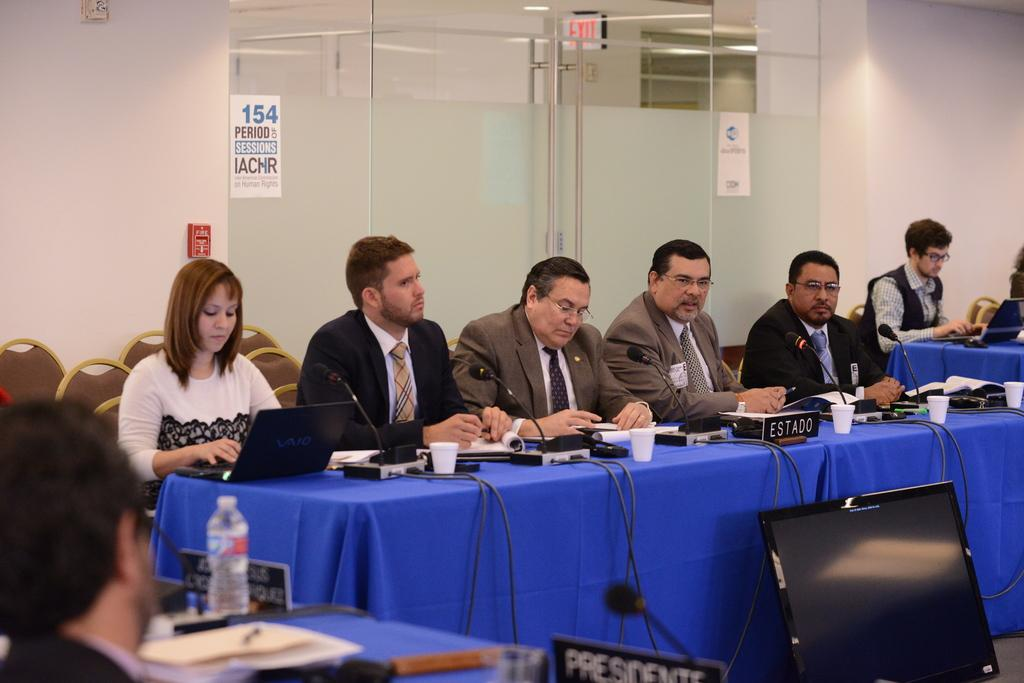<image>
Render a clear and concise summary of the photo. Five people sit at a conference table behind a name placard that says estado. 